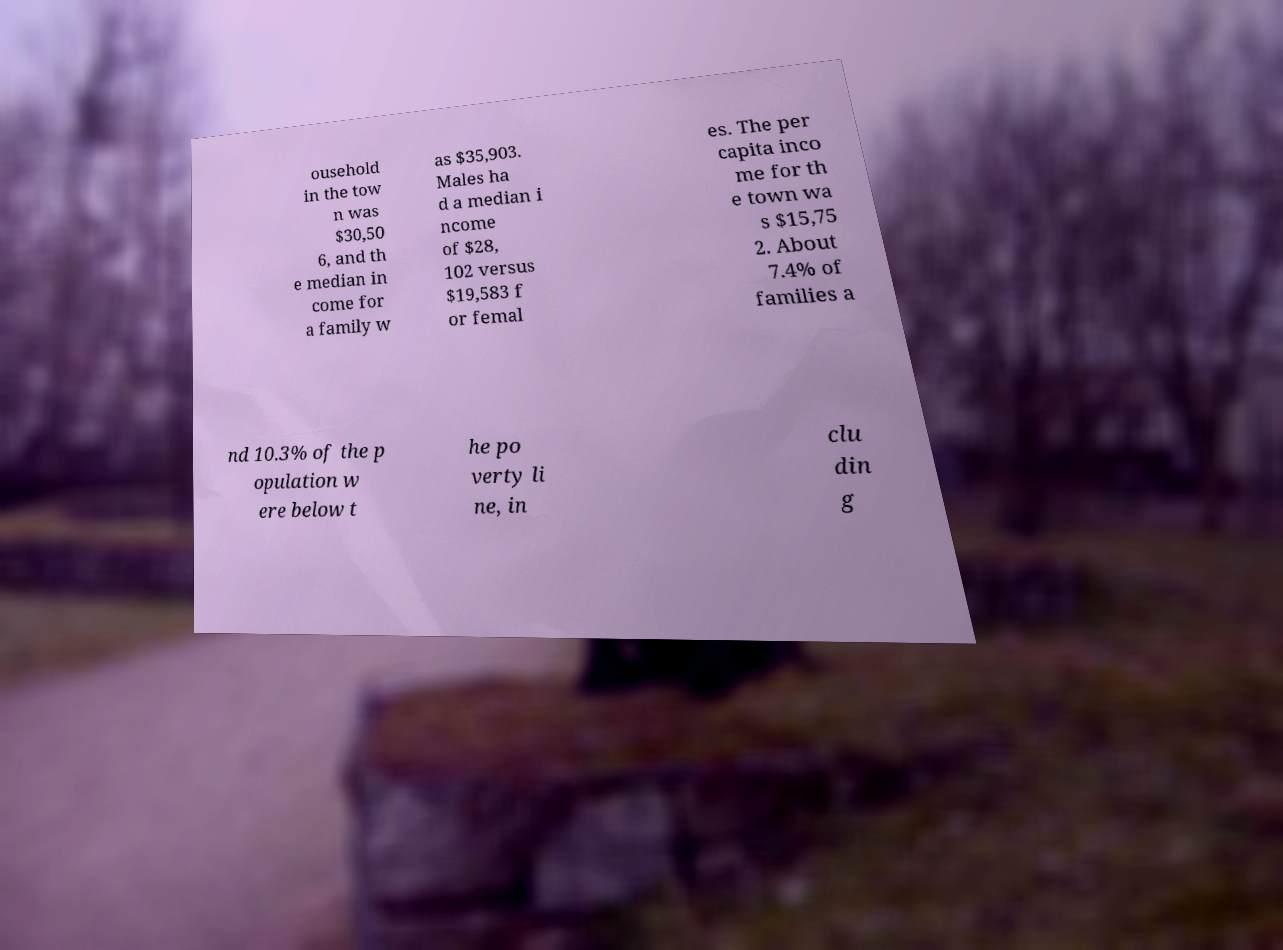Can you accurately transcribe the text from the provided image for me? ousehold in the tow n was $30,50 6, and th e median in come for a family w as $35,903. Males ha d a median i ncome of $28, 102 versus $19,583 f or femal es. The per capita inco me for th e town wa s $15,75 2. About 7.4% of families a nd 10.3% of the p opulation w ere below t he po verty li ne, in clu din g 